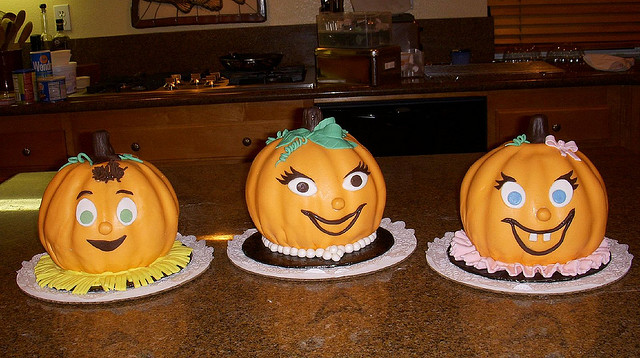Are these decorations typical for Halloween? Yes, pumpkins are a hallmark of Halloween decorations. These cakes take it a step further by not only mimicking the traditional pumpkin shape but also by giving them anthropomorphic features that tie in with the fun and creative aspects associated with Halloween festivities.  What type of techniques could have been used to create these cakes? The baker would have used a variety of cake decorating techniques, such as sculpting the cakes to have a rounded pumpkin shape, using fondant to create the smooth facial features and accessories, and applying icing or edible paint for the finer details like the eyes and mouth. These techniques require skill and artistic ability to achieve the thematic and cheerful look. 